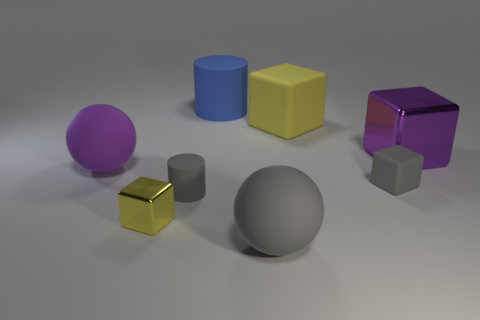There is a purple object that is the same shape as the yellow metallic thing; what is its material?
Give a very brief answer. Metal. What color is the tiny rubber cube?
Your answer should be very brief. Gray. How many other things are the same color as the big metallic block?
Provide a succinct answer. 1. There is a small metal object; are there any purple objects behind it?
Your response must be concise. Yes. What is the color of the ball on the right side of the rubber sphere that is behind the tiny cube in front of the tiny gray rubber block?
Make the answer very short. Gray. What number of gray rubber things are behind the small yellow metallic cube and on the right side of the blue rubber thing?
Offer a terse response. 1. How many cylinders are small gray rubber objects or big objects?
Provide a succinct answer. 2. Are there any yellow objects?
Give a very brief answer. Yes. What number of other things are there of the same material as the large blue cylinder
Make the answer very short. 5. There is a yellow cube that is the same size as the purple sphere; what material is it?
Your response must be concise. Rubber. 